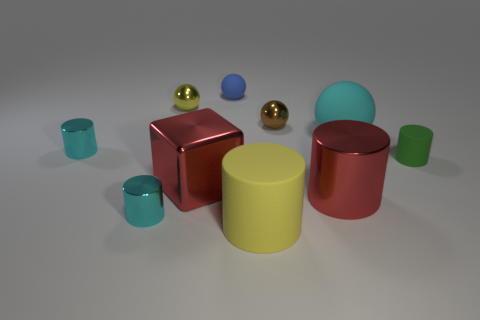Subtract all tiny blue spheres. How many spheres are left? 3 Subtract all brown spheres. How many cyan cylinders are left? 2 Subtract all red cylinders. How many cylinders are left? 4 Subtract 4 cylinders. How many cylinders are left? 1 Subtract all gray balls. Subtract all green blocks. How many balls are left? 4 Add 7 tiny brown matte objects. How many tiny brown matte objects exist? 7 Subtract 1 cyan cylinders. How many objects are left? 9 Subtract all spheres. How many objects are left? 6 Subtract all tiny green rubber cylinders. Subtract all blue objects. How many objects are left? 8 Add 7 red shiny objects. How many red shiny objects are left? 9 